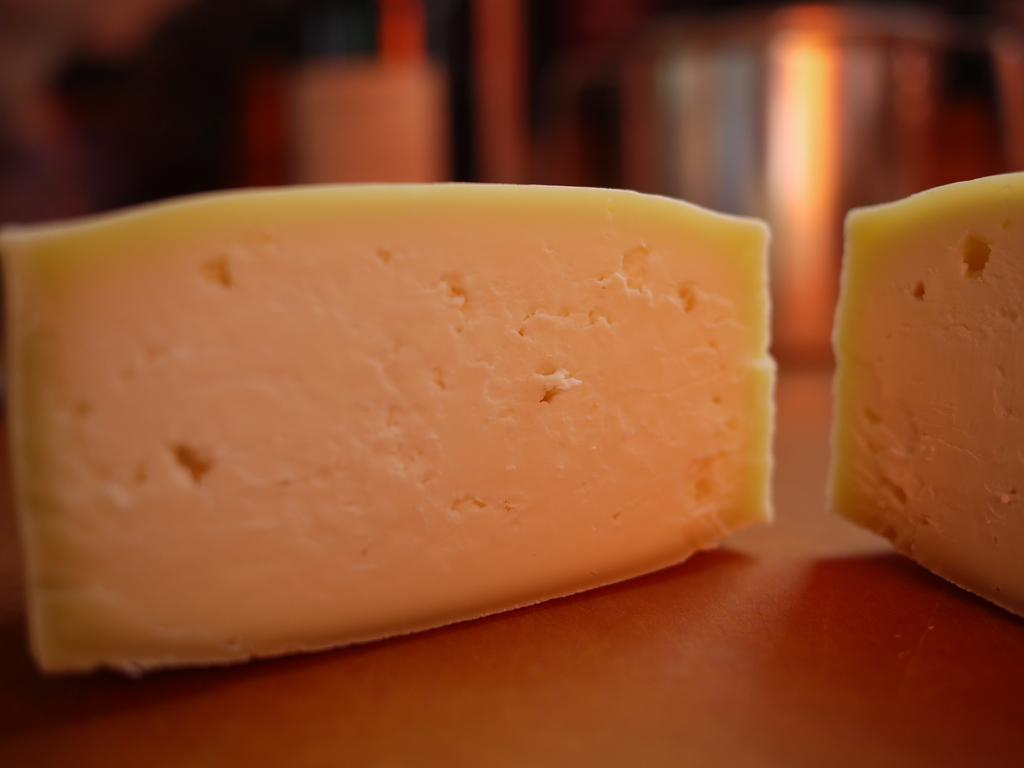What is placed on the wooden platform in the image? There is food on a wooden platform in the image. Can you describe the background of the image? The background of the image is blurry. How many frogs can be seen on the farm in the image? There is no farm or frogs present in the image; it only features food on a wooden platform with a blurry background. 